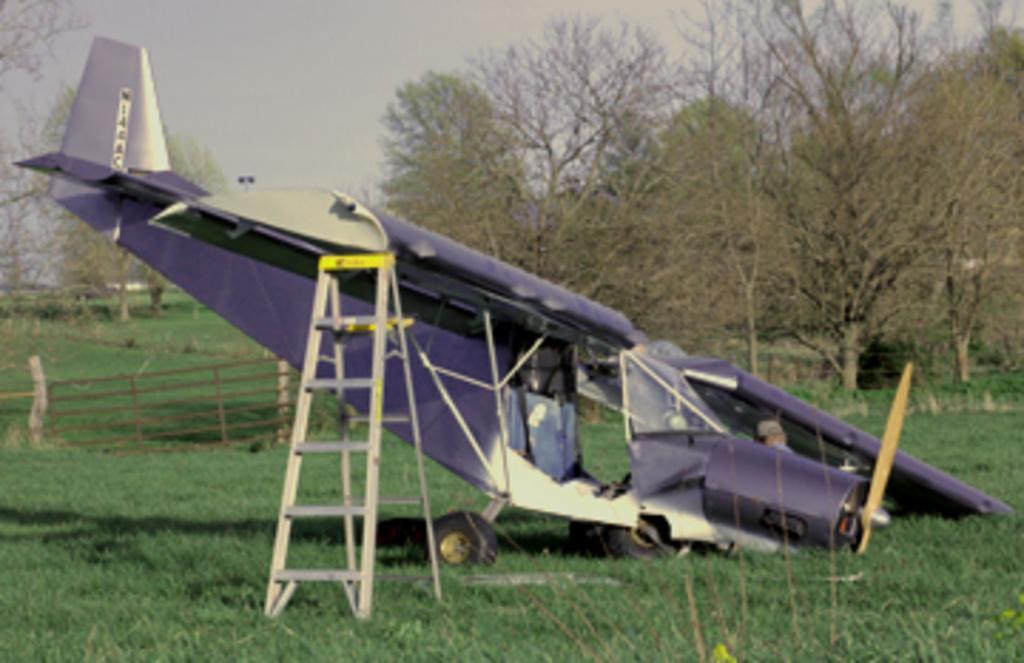Describe this image in one or two sentences. In this image we can see an aeroplane. In the background we can see wooden fence, trees, grass, extendable ladder and sky. 